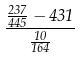<formula> <loc_0><loc_0><loc_500><loc_500>\frac { \frac { 2 3 7 } { 4 4 5 } - 4 3 1 } { \frac { 1 0 } { 1 6 4 } }</formula> 